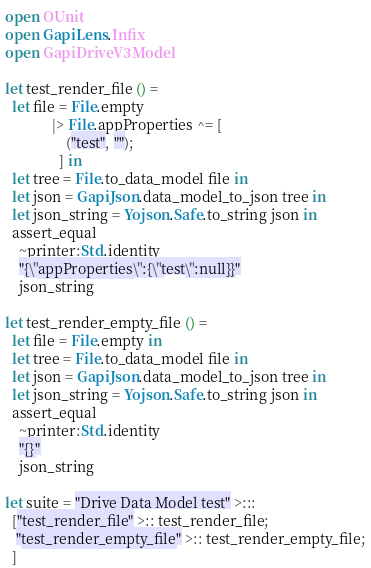<code> <loc_0><loc_0><loc_500><loc_500><_OCaml_>open OUnit
open GapiLens.Infix
open GapiDriveV3Model

let test_render_file () =
  let file = File.empty
             |> File.appProperties ^= [
                 ("test", "");
               ] in
  let tree = File.to_data_model file in
  let json = GapiJson.data_model_to_json tree in
  let json_string = Yojson.Safe.to_string json in
  assert_equal
    ~printer:Std.identity
    "{\"appProperties\":{\"test\":null}}"
    json_string

let test_render_empty_file () =
  let file = File.empty in
  let tree = File.to_data_model file in
  let json = GapiJson.data_model_to_json tree in
  let json_string = Yojson.Safe.to_string json in
  assert_equal
    ~printer:Std.identity
    "{}"
    json_string

let suite = "Drive Data Model test" >:::
  ["test_render_file" >:: test_render_file;
   "test_render_empty_file" >:: test_render_empty_file;
  ]

</code> 